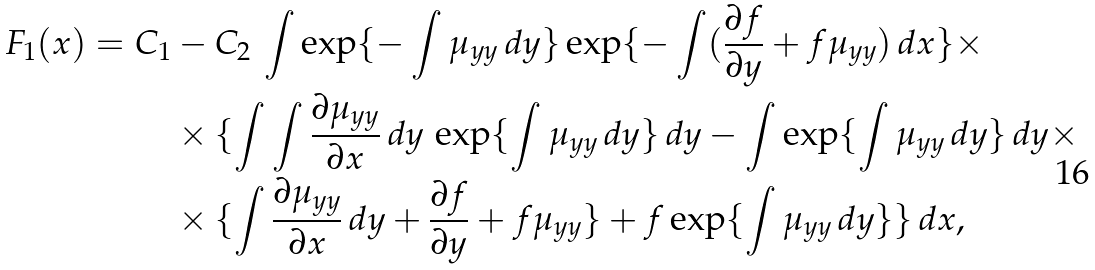<formula> <loc_0><loc_0><loc_500><loc_500>F _ { 1 } ( x ) = C _ { 1 } & - C _ { 2 } \, \int \exp \{ - \int \mu _ { y y } \, d y \} \exp \{ - \int ( \frac { \partial f } { \partial y } + f \mu _ { y y } ) \, d x \} \times \\ & \times \{ \int \int \frac { \partial \mu _ { y y } } { \partial x } \, d y \, \exp \{ \int \mu _ { y y } \, d y \} \, d y - \int \exp \{ \int \mu _ { y y } \, d y \} \, d y \times \\ & \times \{ \int \frac { \partial \mu _ { y y } } { \partial x } \, d y + \frac { \partial f } { \partial y } + f \mu _ { y y } \} + f \exp \{ \int \mu _ { y y } \, d y \} \} \, d x ,</formula> 